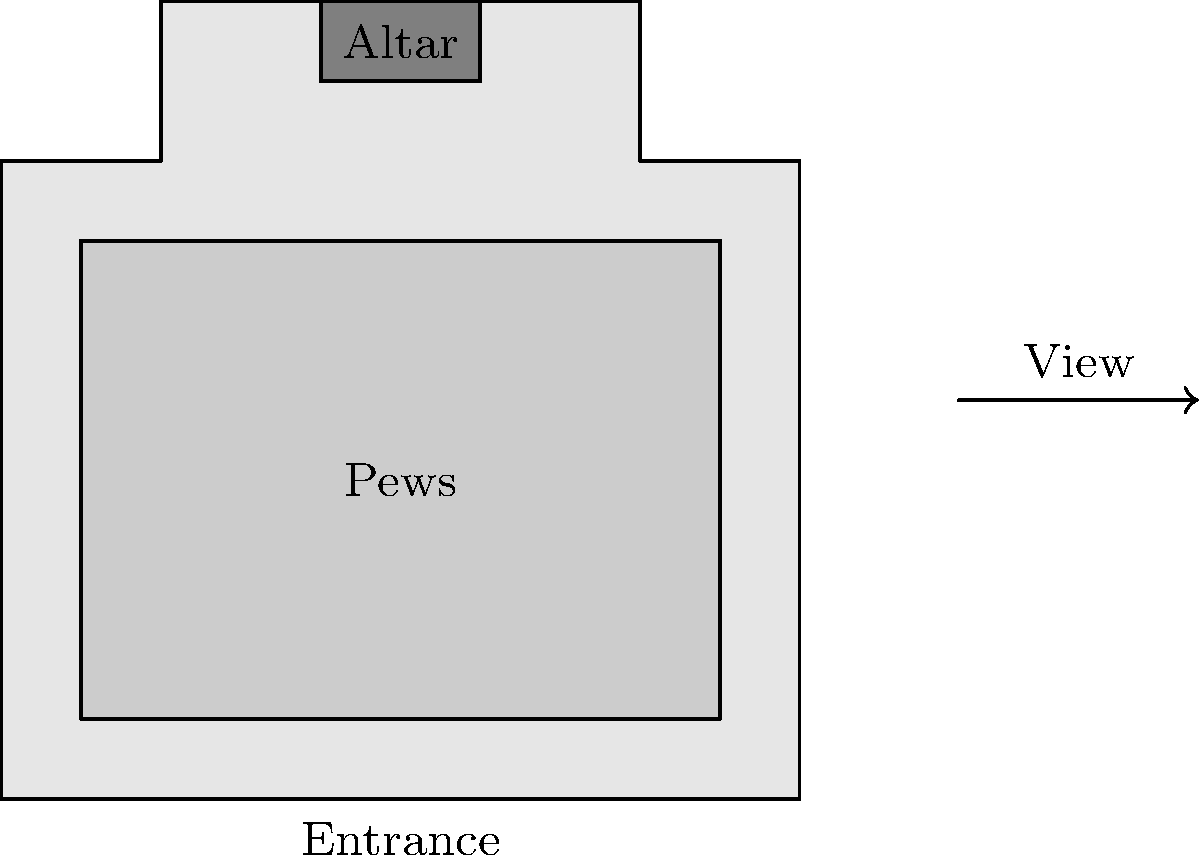As you enter Emmanuel Chapel in Wimbledon, you notice an unfamiliar layout. If you were to view the church from the arrow's perspective (outside the right wall), which of the following statements about the altar's position would be correct?

A) The altar would appear on your left
B) The altar would appear on your right
C) The altar would be directly in front of you
D) The altar would not be visible from this angle To solve this problem, let's follow these steps:

1. Understand the given floor plan:
   - The entrance is at the bottom of the diagram.
   - The altar is located at the top of the diagram.
   - The arrow indicates a viewing position outside the right wall.

2. Visualize rotating the floor plan 90 degrees counterclockwise:
   - This rotation aligns the view with the arrow's perspective.

3. After the mental rotation:
   - The entrance would now be on your right.
   - The altar would now be on your left.

4. Consider the visibility:
   - From the arrow's position, you would be looking through the right wall.
   - The altar is not obstructed by any walls from this angle.

5. Conclude the altar's position:
   - The altar would be visible and appear on your left side when viewing from the arrow's perspective.
Answer: A) The altar would appear on your left 